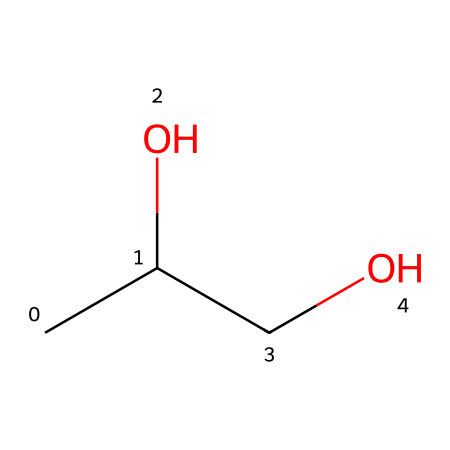What is the name of this chemical? The chemical with the SMILES representation CC(O)CO corresponds to propylene glycol, which is commonly known as a humectant and stabilizer in food products.
Answer: propylene glycol How many carbon atoms are in the chemical structure? By examining the SMILES representation, there are three carbon atoms present (C, C, C), indicating a total of three carbon atoms in the molecular structure of propylene glycol.
Answer: 3 What type of functional group is present in this molecule? The SMILES shows the presence of an alcohol group (indicated by the -OH part of the structure), which classifies propylene glycol as having hydroxyl functional groups.
Answer: alcohol How many hydroxyl (-OH) groups does the structure contain? Reviewing the structure, there are two hydroxyl groups shown as -OH in the SMILES representation, indicating that propylene glycol is a diol.
Answer: 2 What is the molecular formula of this compound? The components indicated in the SMILES consist of 3 carbon atoms, 8 hydrogen atoms, and 2 oxygen atoms, resulting in the molecular formula C3H8O2 for propylene glycol.
Answer: C3H8O2 What property makes propylene glycol an effective humectant? The presence of hydroxyl groups allows propylene glycol to attract and retain moisture, which is vital for its effectiveness as a humectant in food products.
Answer: moisture retention Why is propylene glycol used in food products? Propylene glycol's role as a stabilizer and humectant is due to its ability to maintain moisture and improve the texture of food products, providing better taste and shelf life.
Answer: stabilizer and humectant 